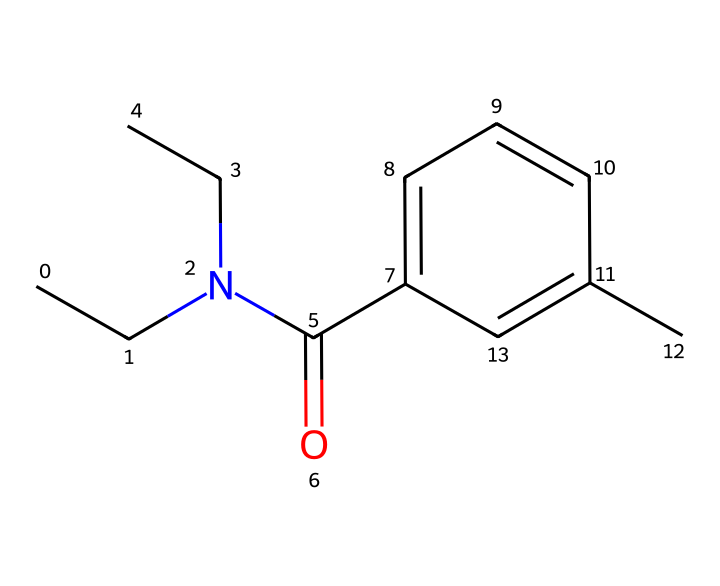How many carbon atoms are in DEET? In the provided SMILES representation, we can count the number of carbon (C) atoms. There are a total of 10 carbon atoms highlighted in the structure, illustrated by the "C" letters in the SMILES.
Answer: 10 What functional group is present in DEET? The SMILES indicates a carbonyl group (C=O) due to the "=O" following a carbon, which signifies that there is a carbon atom double-bonded to an oxygen atom.
Answer: carbonyl How many nitrogen atoms are in DEET? The nitrogen (N) atom can be identified in the SMILES as it appears explicitly with "N," and there is only one nitrogen atom visible in the structure.
Answer: 1 Does DEET contain any aromatic rings? Analyzing the structure, we observe that there is a benzene ring (indicated by alternating double bonds in the carbon segment) at the end of the SMILES, suggesting the presence of an aromatic ring.
Answer: yes What type of pesticide classification does DEET fall under? DEET is primarily classified as an insect repellent, which categorizes it within the pesticide class that is specifically designed to repel insects rather than kill them outright.
Answer: insect repellent How many double bonds are present in DEET? By examining the SMILES, we can identify double bonds; there are two double bonds in the structure. One is in the carbonyl (C=O) and the other can be found within the aromatic ring.
Answer: 2 What is the overall charge of DEET? Since the structure contains only neutral atoms (not specified with charges in the SMILES), we deduce that the overall charge of DEET is neutral, meaning there are no extra positive or negative charges present in the compound.
Answer: neutral 